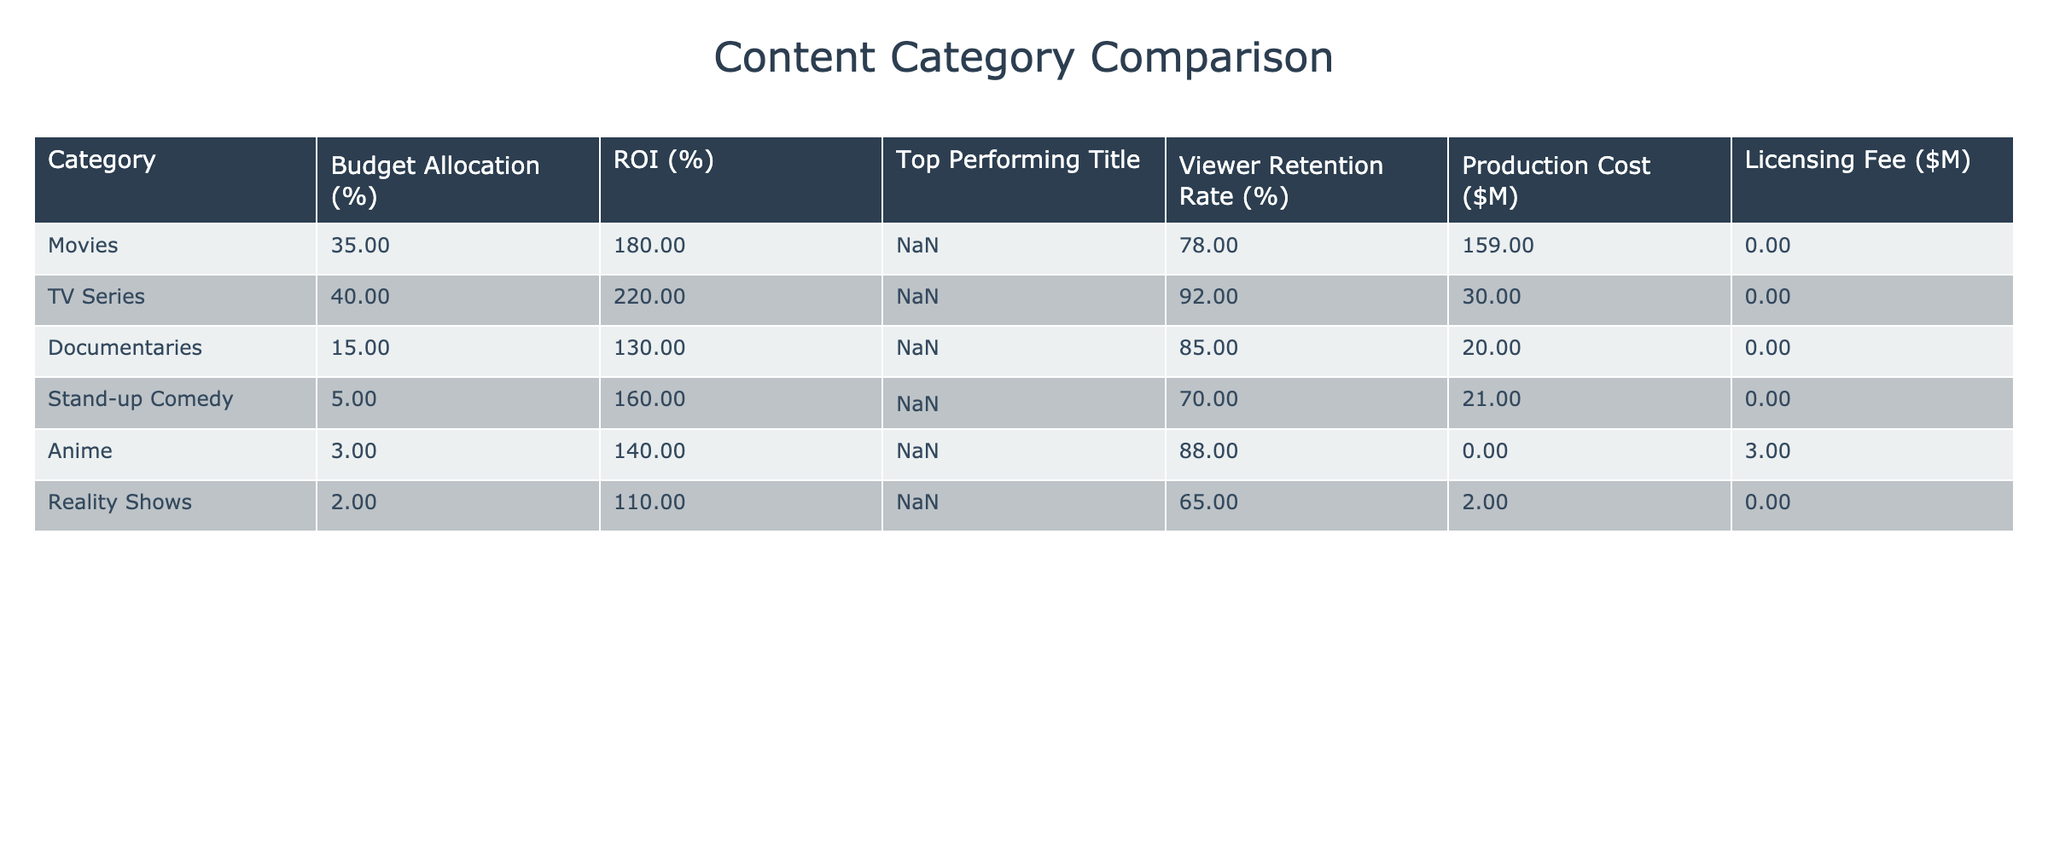What is the budget allocation percentage for TV Series? The table shows that the budget allocation for TV Series is 40%. This can be directly retrieved from the corresponding column in the table.
Answer: 40% Which content category has the highest ROI? By evaluating the ROI percentages in the table, TV Series has the highest ROI at 220%. This is determined by comparing all the ROI values listed for each category.
Answer: TV Series What is the average viewer retention rate for Movies and Documentaries combined? The viewer retention rates for Movies and Documentaries are 78% and 85%, respectively. To find the average: (78 + 85) / 2 = 81.5%. Therefore, the average viewer retention rate is calculated from these two values.
Answer: 81.5% Is the production cost for Stand-up Comedy higher than that for Anime? The production cost for Stand-up Comedy is $21 million, while for Anime it is $0 million. Since 21 is greater than 0, the statement is true. This is easily determined by directly comparing the production costs in the table.
Answer: Yes What is the total budget allocation percentage for the content categories with an ROI of 130% or higher? The content categories with an ROI of 130% or higher are Movies (180%), TV Series (220%), Documentaries (130%), and Stand-up Comedy (160%). Their budget allocations are 35%, 40%, 15%, and 5%, respectively. Adding these percentages together: 35 + 40 + 15 + 5 = 95%. This involves summing the allocations for each identified category.
Answer: 95% Which category has both the highest viewer retention rate and contributes the highest percentage of budget allocation? TV Series has the highest viewer retention rate at 92% and allocates 40% of the budget. While analyzing the table, we find these two metrics are most favorable in the TV Series category compared to others.
Answer: TV Series Does the category with the lowest budget allocation also have the lowest production cost? Yes, the category with the lowest budget allocation is Reality Shows at 2%, which has a production cost of $2 million. Since there is no category allocated a lower budget that has a lower production cost, the statement holds true.
Answer: Yes What is the difference in ROI between TV Series and Documentaries? The ROI for TV Series is 220% and for Documentaries it is 130%. To find the difference, subtract the lower ROI from the higher ROI: 220 - 130 = 90%. This calculation involves basic subtraction of the two ROI values.
Answer: 90% 